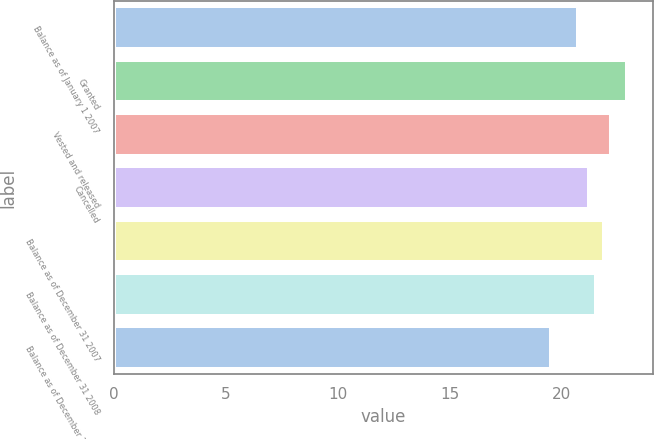Convert chart. <chart><loc_0><loc_0><loc_500><loc_500><bar_chart><fcel>Balance as of January 1 2007<fcel>Granted<fcel>Vested and released<fcel>Cancelled<fcel>Balance as of December 31 2007<fcel>Balance as of December 31 2008<fcel>Balance as of December 31 2009<nl><fcel>20.72<fcel>22.92<fcel>22.22<fcel>21.2<fcel>21.88<fcel>21.54<fcel>19.5<nl></chart> 